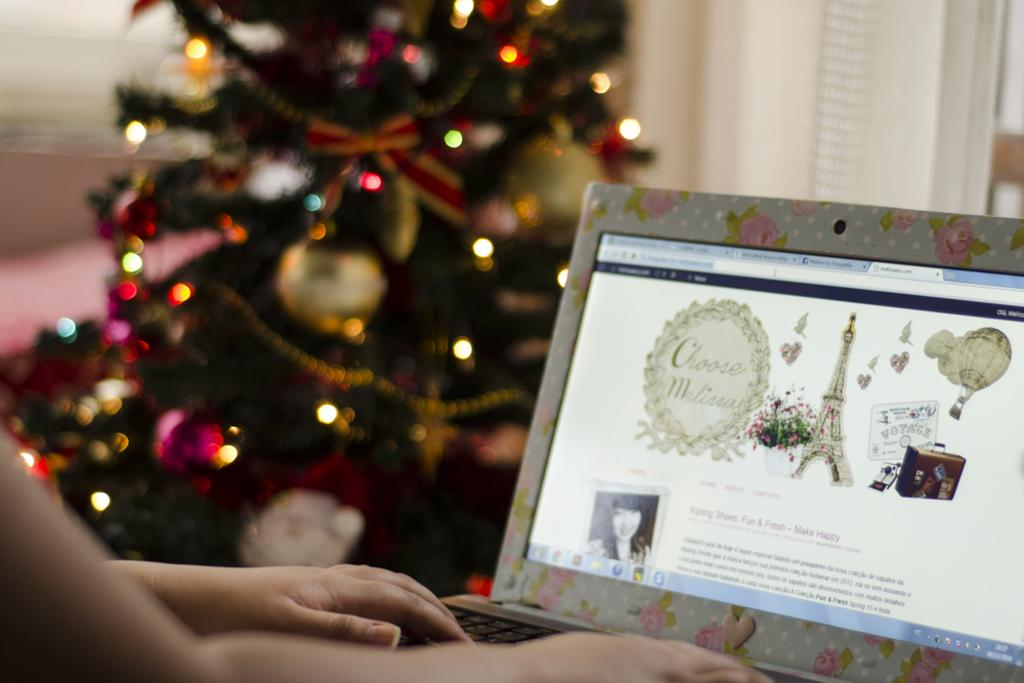What body part is visible in the image? There are hands of a person in the image. What electronic device is present in the image? There is a laptop in the image. Can you describe the background of the image? The background of the image is blurred. What seasonal decoration can be seen in the image? There is a Christmas tree in the image. How many kittens are sitting on the minister's lap in the image? There are no kittens or minister present in the image. What type of wine is being served in the image? There is no wine present in the image. 